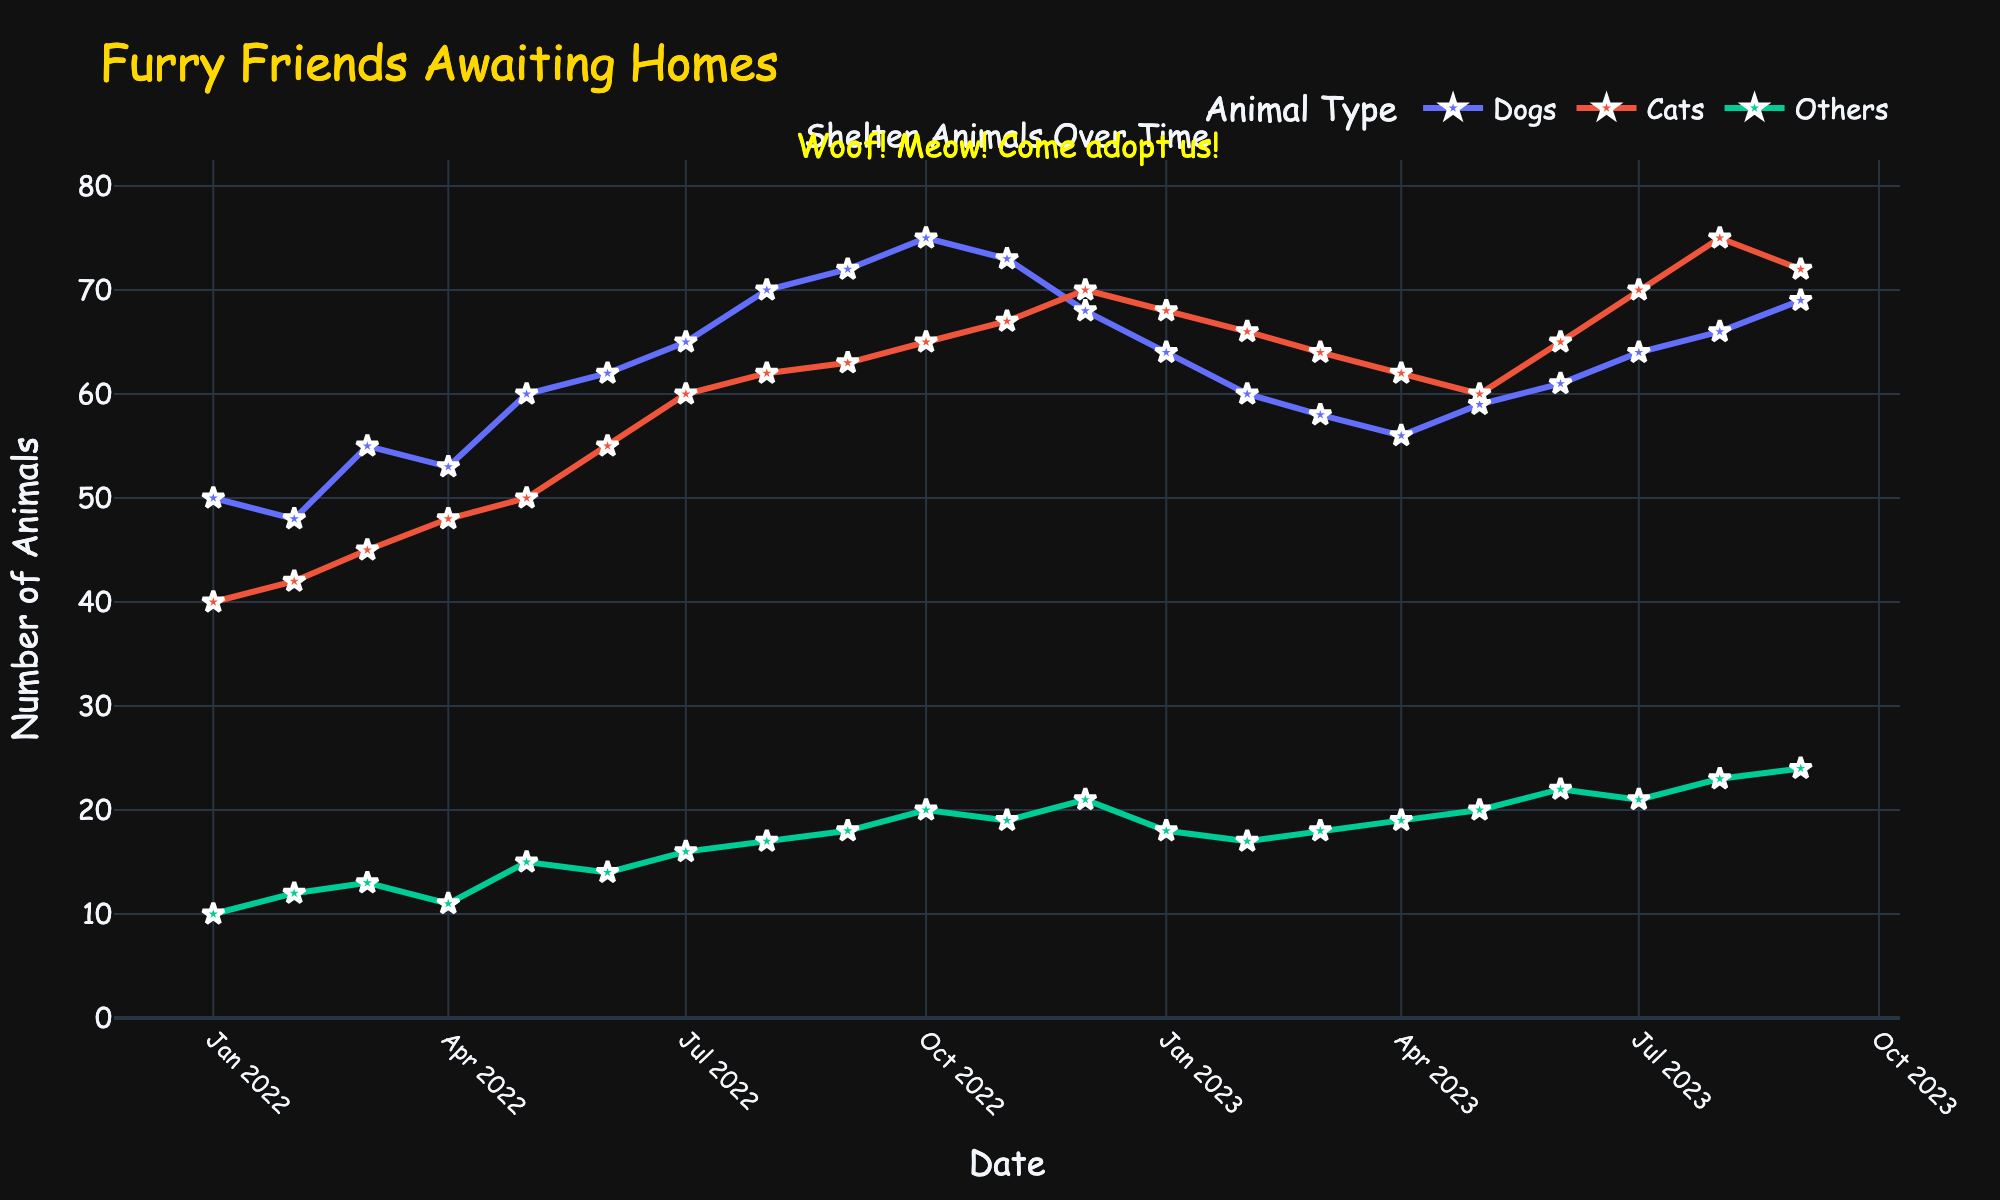What's the title of the figure? The title is usually at the top of the figure and provides an overview of what the figure represents. In this case, it’s labeled "Furry Friends Awaiting Homes".
Answer: Furry Friends Awaiting Homes Which species had the highest number of animals in December 2022? Look at the data point corresponding to December 2022 for each species (Dogs, Cats, Others) and compare the values.
Answer: Cats What was the number of dogs in July 2023? Locate the data point for dogs in July 2023 on the plot and read the corresponding value.
Answer: 64 Which month had the lowest number of cats in 2023? Look at the graph for 2023 and identify the data points for Cats across each month, comparing their values to find the lowest one.
Answer: May How did the number of dogs change from February 2022 to February 2023? Check the values of dogs for both February 2022 and February 2023 and calculate the difference: 48 (Feb 2022) - 60 (Feb 2023) = -12.
Answer: Decreased by 12 What is the overall trend in the number of shelter animals from 2022 to 2023? Observe the patterns of the lines representing species from January 2022 to September 2023. Each species generally shows an increasing or decreasing trend over time, but a slight fluctuation in mid-2023.
Answer: General increase Which species shows the most consistent increase over time? By examining the slopes of the lines, check which species has the most steadily increasing pattern without major fluctuations.
Answer: Cats What is the average number of 'Others' animals in 2023 so far? Sum the number of 'Others' animals from January 2023 to September 2023 and divide by the number of months: (18 + 17 + 18 + 19 + 20 + 22 + 21 + 23 + 24) / 9. This results in 20.22.
Answer: 20.22 In which month of 2022 did dogs peak? Find the peak value of the dogs' line for 2022 and check which month it occurs. It's highest in October 2022.
Answer: October How does the number of cats in July 2022 compare to July 2023? Compare the values of cats for both time points: 60 (July 2022) and 70 (July 2023). The number has increased from one year to the next.
Answer: Increased 